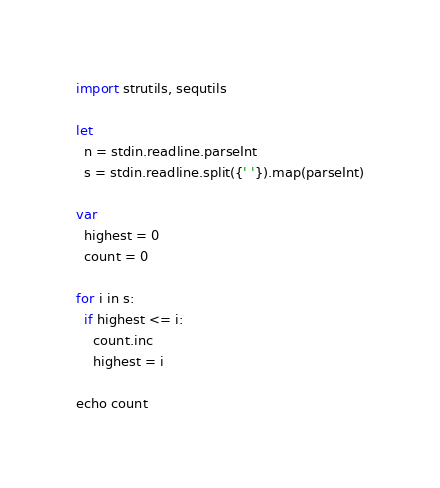<code> <loc_0><loc_0><loc_500><loc_500><_Nim_>import strutils, sequtils

let
  n = stdin.readline.parseInt
  s = stdin.readline.split({' '}).map(parseInt)

var
  highest = 0
  count = 0

for i in s:
  if highest <= i:
    count.inc
    highest = i

echo count</code> 